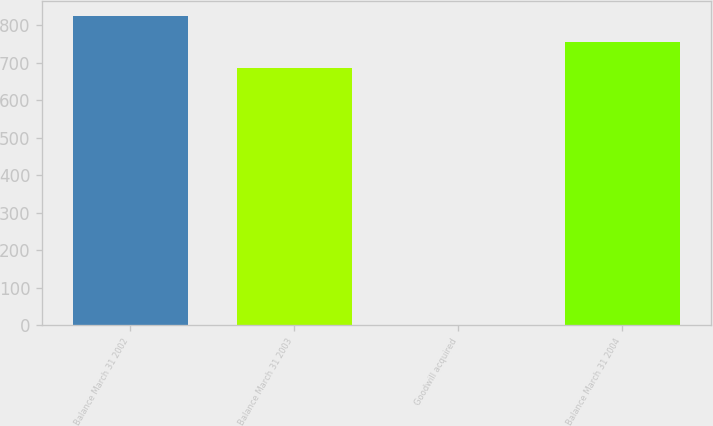Convert chart to OTSL. <chart><loc_0><loc_0><loc_500><loc_500><bar_chart><fcel>Balance March 31 2002<fcel>Balance March 31 2003<fcel>Goodwill acquired<fcel>Balance March 31 2004<nl><fcel>824.18<fcel>686.5<fcel>1<fcel>755.34<nl></chart> 